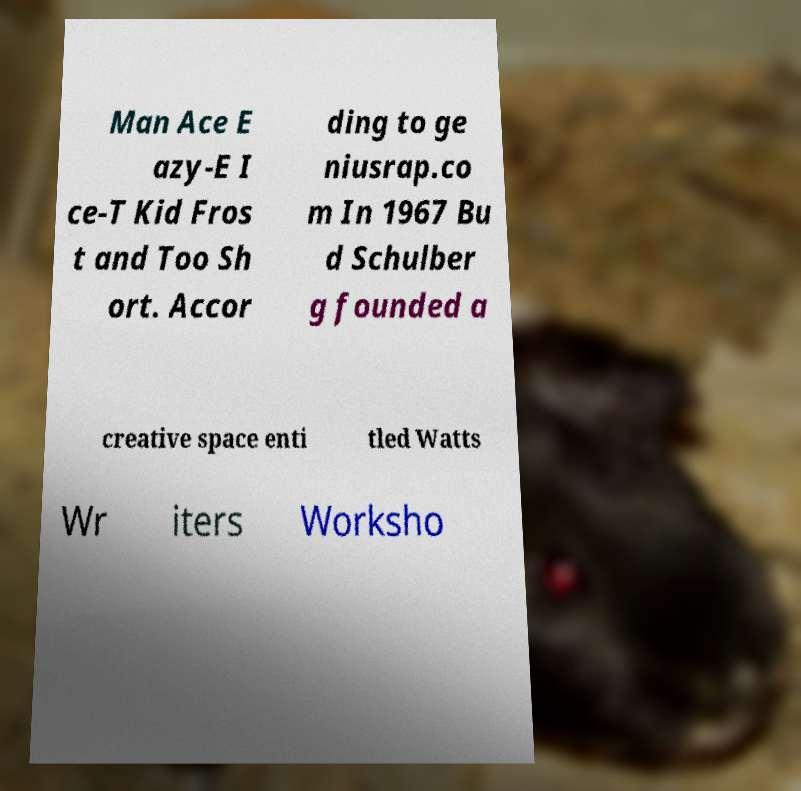Could you extract and type out the text from this image? Man Ace E azy-E I ce-T Kid Fros t and Too Sh ort. Accor ding to ge niusrap.co m In 1967 Bu d Schulber g founded a creative space enti tled Watts Wr iters Worksho 